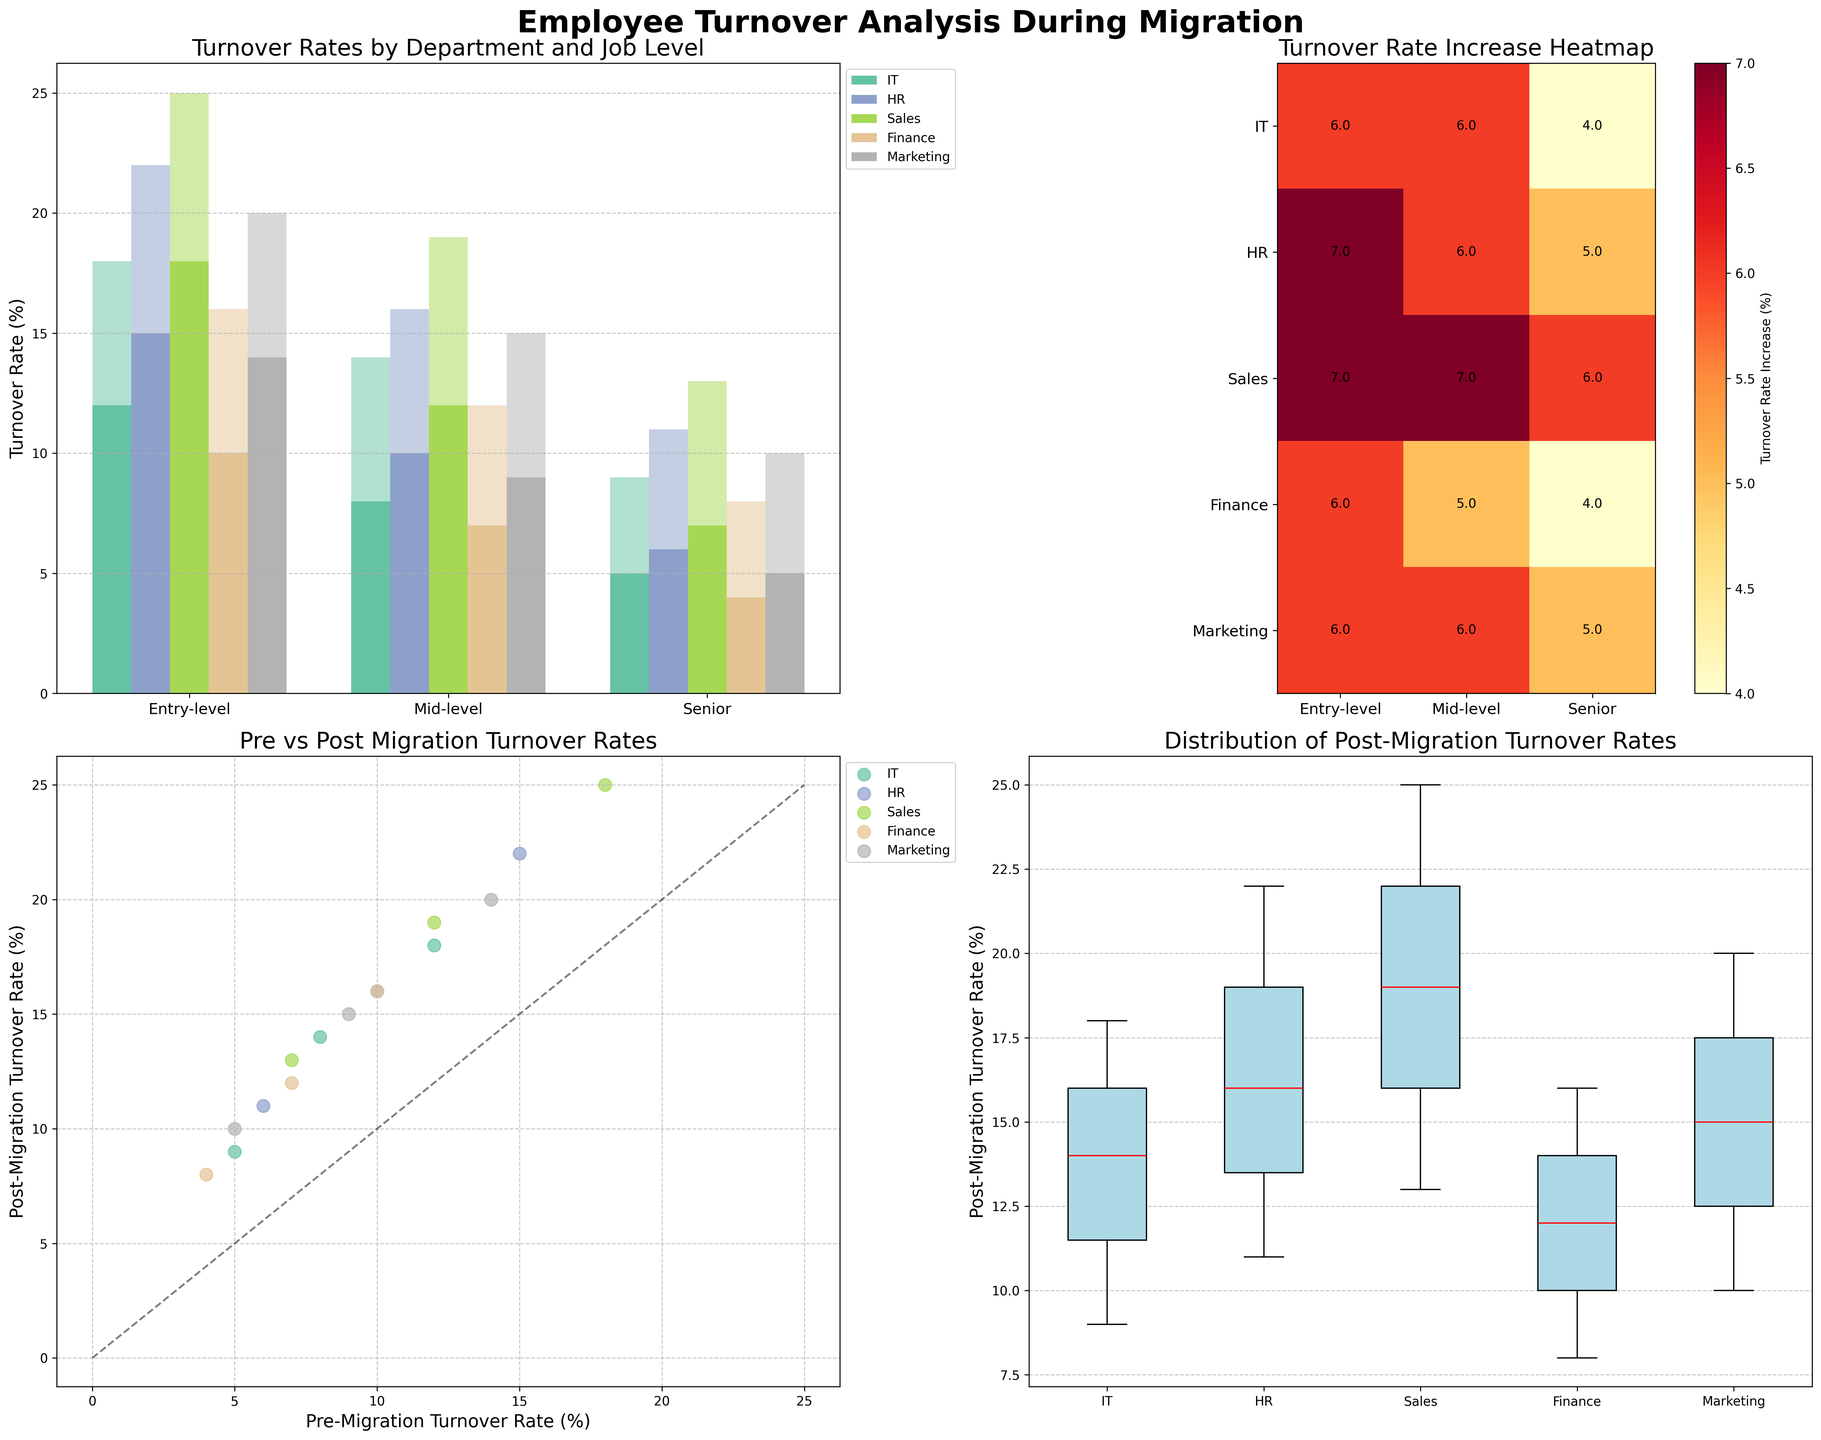What's the turnover rate for entry-level employees in the Sales department before and after the migration? In the grouped bar chart (Subplot 1), identify the bars that represent entry-level Sales employees. The bars indicate the pre-migration turnover rate is 18% and the post-migration turnover rate is 25%.
Answer: 18%, 25% Which department saw the highest increase in turnover rates post-migration? In the heatmap (Subplot 2), locate the highest value. The department with the highest rate increase is Sales at the entry-level with a turnover rate increase of 7%, indicating Sales had the highest increase.
Answer: Sales What is the median post-migration turnover rate across all departments? In the box plot (Subplot 4), identify the median lines within the boxplots for each department. The medians are approximately: IT (14%), HR (16%), Sales (19%), Finance (12%), Marketing (15%). The overall median of these values is the middle value of the ordered list (14%, 15%, 16%, 19%) = (16%).
Answer: 16% Compare the turnover rates of mid-level employees in the IT and HR departments post-migration. Which is higher? In the grouped bar chart (Subplot 1), find the bars for mid-level IT and HR employees. The post-migration turnover rates are 14% for IT and 16% for HR, making HR higher.
Answer: HR What does the diagonal line in the scatter plot represent? The diagonal line in Subplot 3 represents the scenario where the pre-migration turnover rate is equal to the post-migration turnover rate. Any point above the line indicates an increase in turnover post-migration, and any point below indicates a decrease.
Answer: Equal rates Which job level in IT experienced the smallest increase in turnover rate post-migration? In the heatmap (Subplot 2), look for the IT department rows. The entry for senior-level IT employees shows the smallest increase (4%) compared to other job levels.
Answer: Senior-level How does the post-migration turnover rate for finance compare across all levels in the scatter plot? In the scatter plot (Subplot 3), locate the Finance department points along the y-axis (post-migration rates). Entry-level (16%), Mid-level (12%), Senior-level (8%). These values show increasing turnover as job level changes from senior to entry-level.
Answer: Increases from senior to entry-level Based on the box plot, which department has the smallest interquartile range for post-migration turnover rates? In the box plot (Subplot 4), examine the width of the boxes representing each department. The IT department's box appears to be the narrowest, indicating the smallest interquartile range.
Answer: IT 